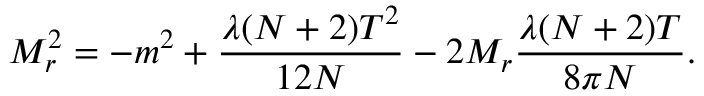<formula> <loc_0><loc_0><loc_500><loc_500>M _ { r } ^ { 2 } = - m ^ { 2 } + \frac { \lambda ( N + 2 ) T ^ { 2 } } { 1 2 N } - 2 M _ { r } \frac { \lambda ( N + 2 ) T } { 8 \pi N } .</formula> 